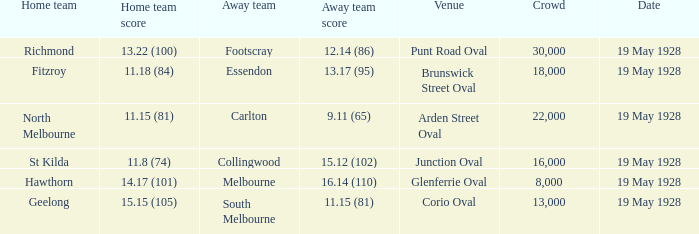What was the listed crowd at junction oval? 16000.0. 